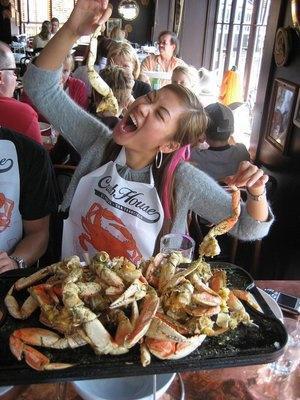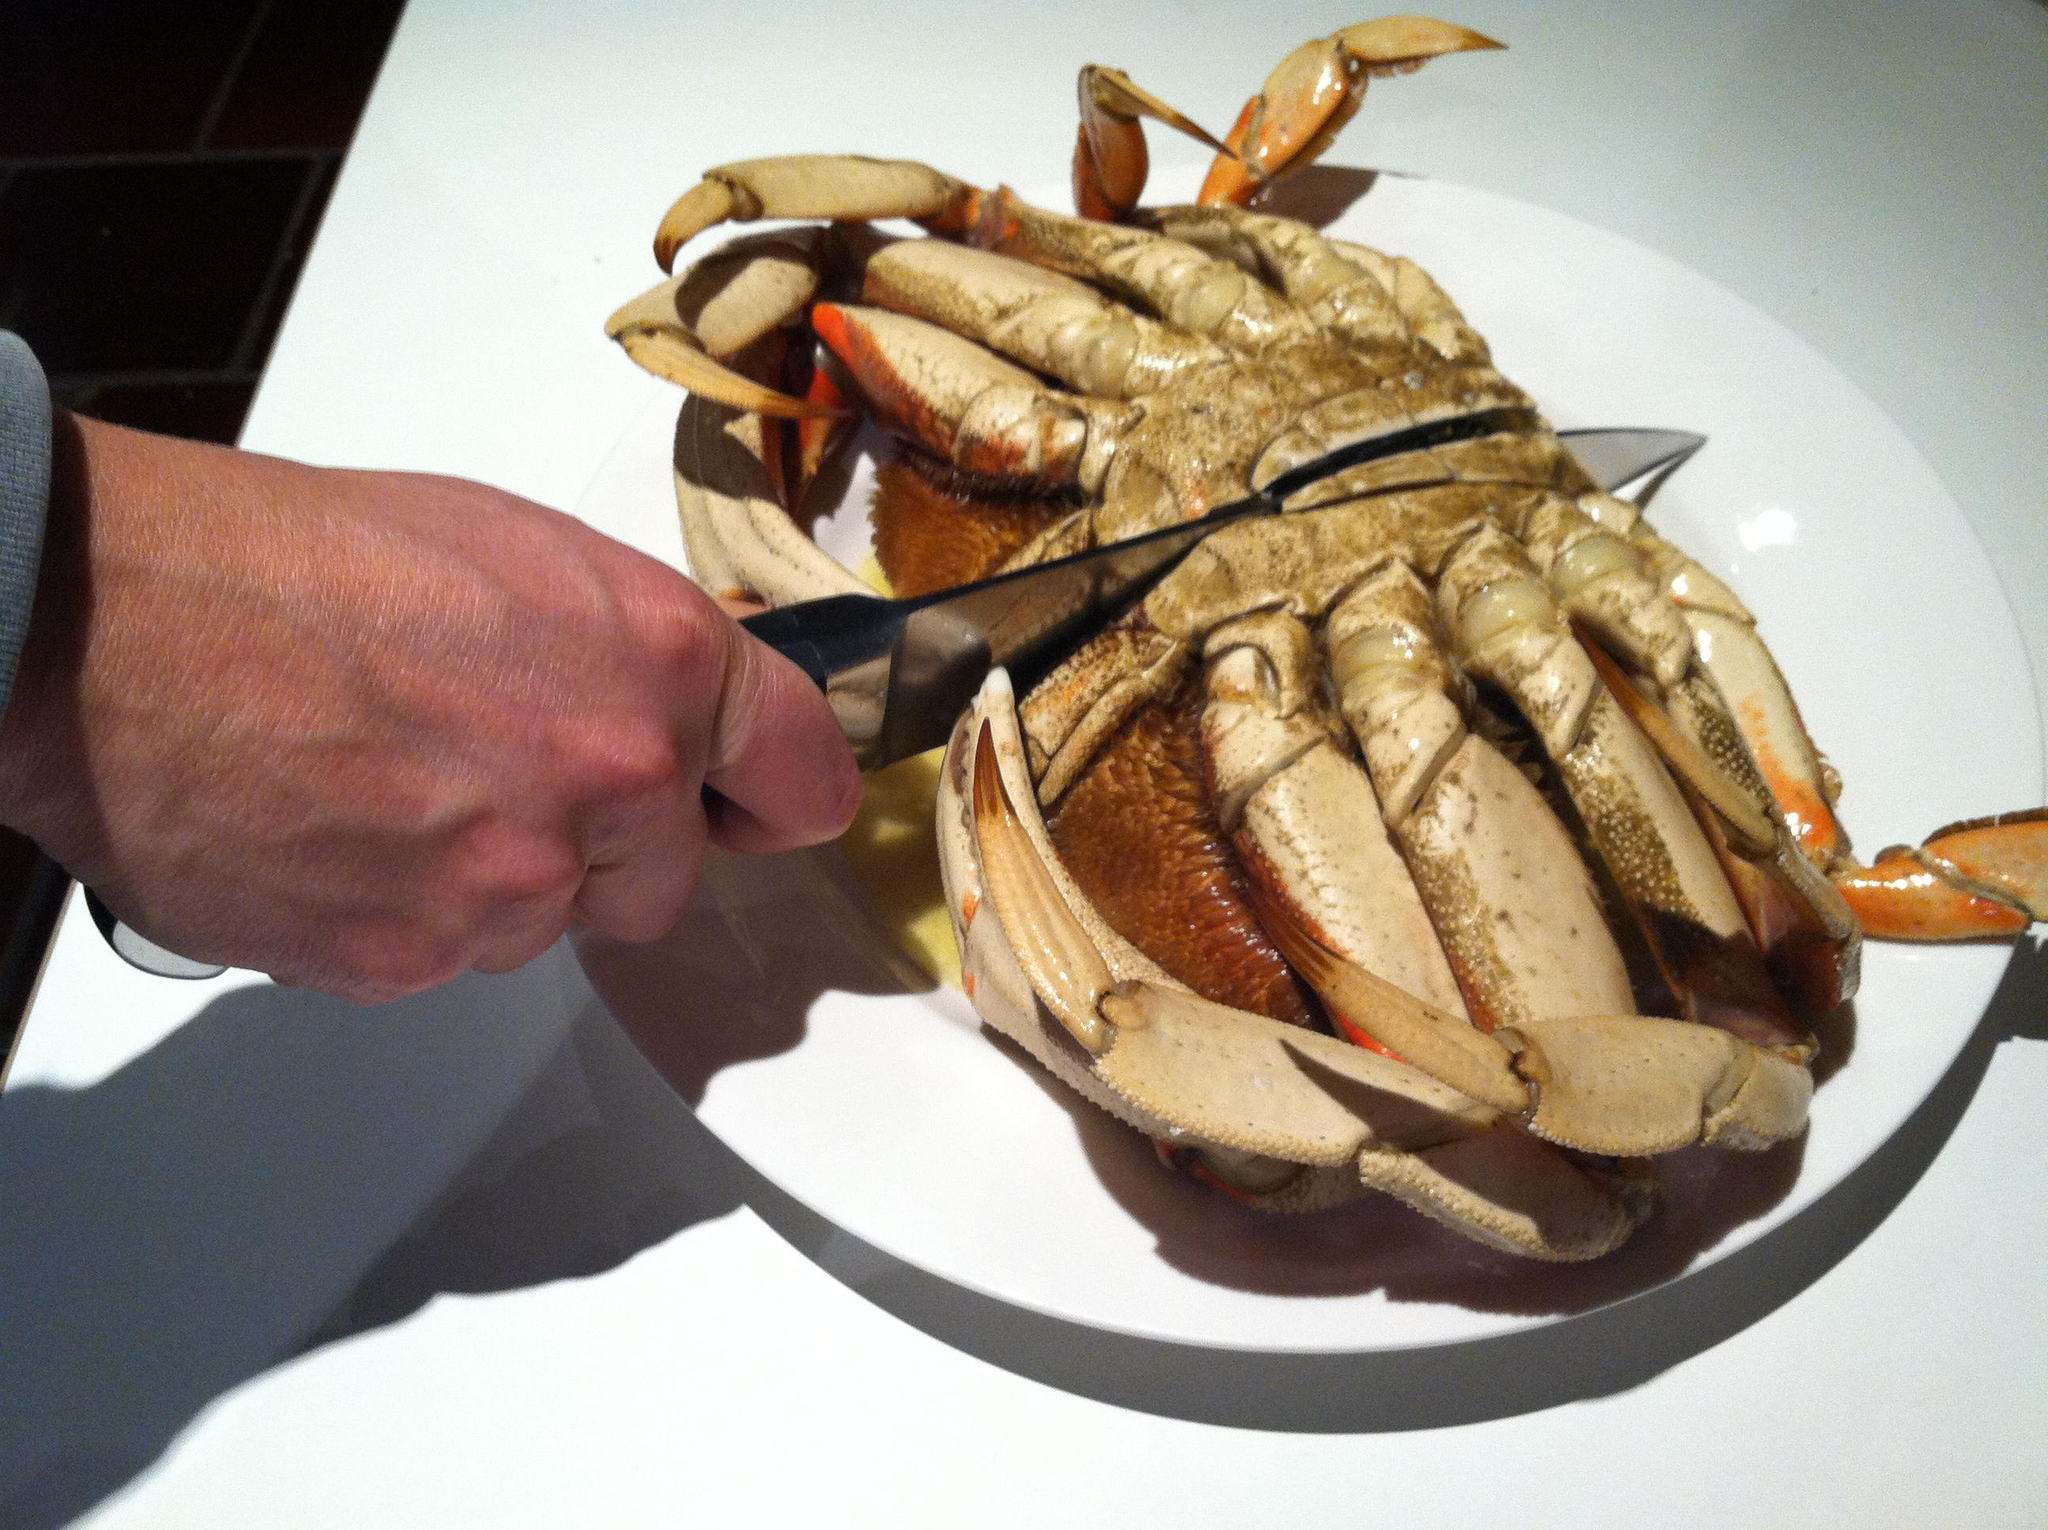The first image is the image on the left, the second image is the image on the right. Analyze the images presented: Is the assertion "A hand is holding up a crab with its face and front claws turned toward the camera in the right image." valid? Answer yes or no. No. The first image is the image on the left, the second image is the image on the right. Evaluate the accuracy of this statement regarding the images: "There are two small white top bottles on either side of two red crabs.". Is it true? Answer yes or no. No. 